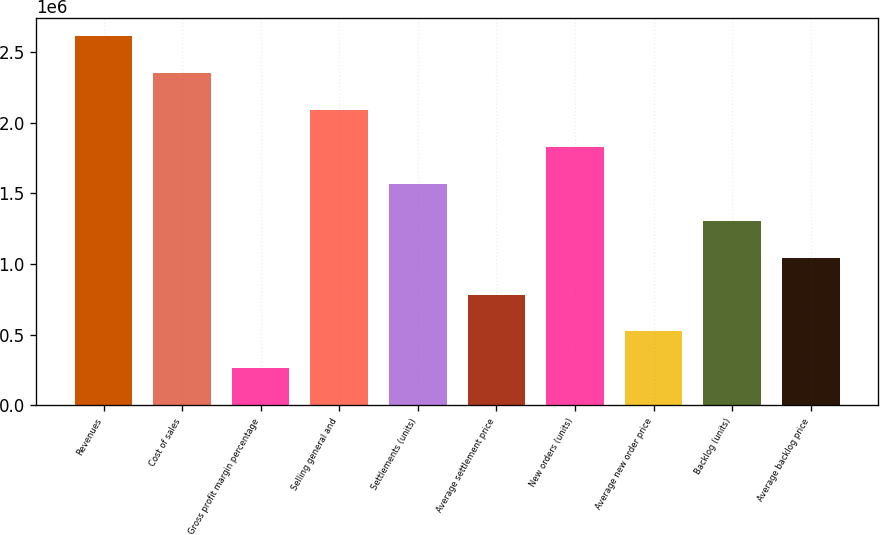<chart> <loc_0><loc_0><loc_500><loc_500><bar_chart><fcel>Revenues<fcel>Cost of sales<fcel>Gross profit margin percentage<fcel>Selling general and<fcel>Settlements (units)<fcel>Average settlement price<fcel>New orders (units)<fcel>Average new order price<fcel>Backlog (units)<fcel>Average backlog price<nl><fcel>2.6112e+06<fcel>2.35008e+06<fcel>261132<fcel>2.08896e+06<fcel>1.56672e+06<fcel>783368<fcel>1.82784e+06<fcel>522250<fcel>1.3056e+06<fcel>1.04449e+06<nl></chart> 